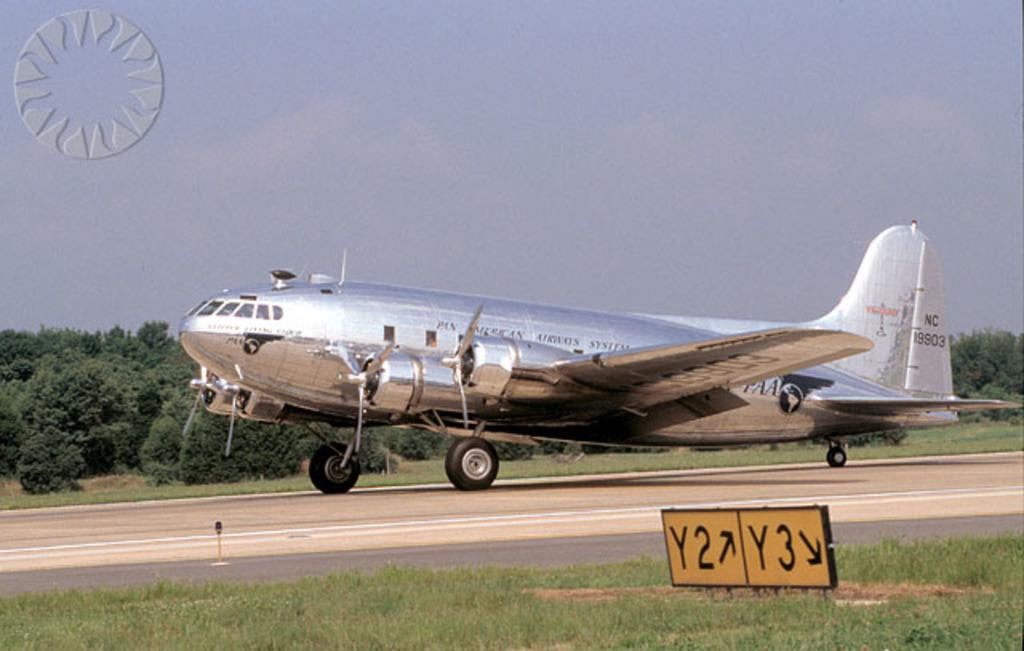<image>
Relay a brief, clear account of the picture shown. A large, silver Pan American Airways System plane is sitting on the runway. 